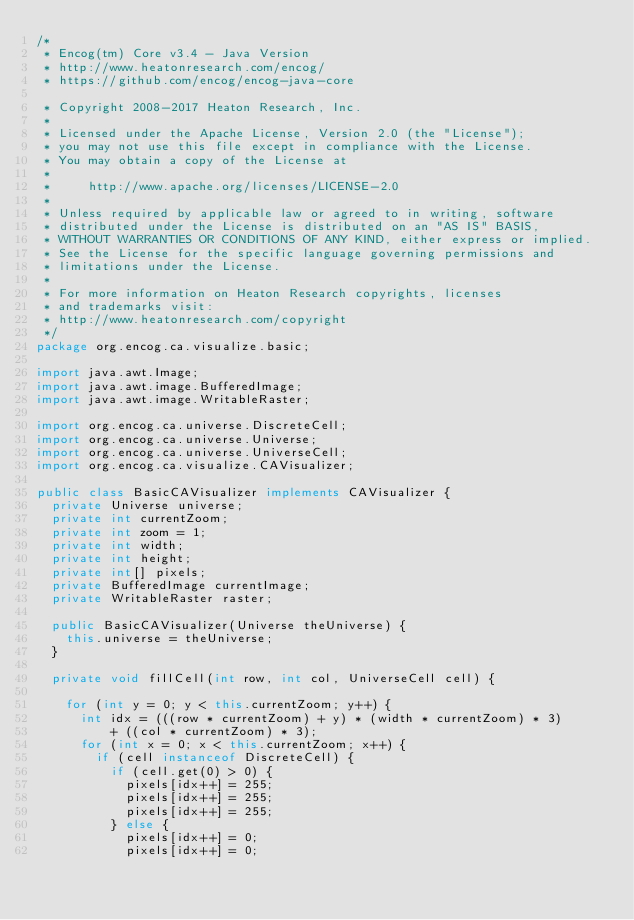<code> <loc_0><loc_0><loc_500><loc_500><_Java_>/*
 * Encog(tm) Core v3.4 - Java Version
 * http://www.heatonresearch.com/encog/
 * https://github.com/encog/encog-java-core
 
 * Copyright 2008-2017 Heaton Research, Inc.
 *
 * Licensed under the Apache License, Version 2.0 (the "License");
 * you may not use this file except in compliance with the License.
 * You may obtain a copy of the License at
 *
 *     http://www.apache.org/licenses/LICENSE-2.0
 *
 * Unless required by applicable law or agreed to in writing, software
 * distributed under the License is distributed on an "AS IS" BASIS,
 * WITHOUT WARRANTIES OR CONDITIONS OF ANY KIND, either express or implied.
 * See the License for the specific language governing permissions and
 * limitations under the License.
 *   
 * For more information on Heaton Research copyrights, licenses 
 * and trademarks visit:
 * http://www.heatonresearch.com/copyright
 */
package org.encog.ca.visualize.basic;

import java.awt.Image;
import java.awt.image.BufferedImage;
import java.awt.image.WritableRaster;

import org.encog.ca.universe.DiscreteCell;
import org.encog.ca.universe.Universe;
import org.encog.ca.universe.UniverseCell;
import org.encog.ca.visualize.CAVisualizer;

public class BasicCAVisualizer implements CAVisualizer {
	private Universe universe;
	private int currentZoom;
	private int zoom = 1;
	private int width;
	private int height;
	private int[] pixels;
	private BufferedImage currentImage;
	private WritableRaster raster;

	public BasicCAVisualizer(Universe theUniverse) {
		this.universe = theUniverse;
	}

	private void fillCell(int row, int col, UniverseCell cell) {

		for (int y = 0; y < this.currentZoom; y++) {
			int idx = (((row * currentZoom) + y) * (width * currentZoom) * 3)
					+ ((col * currentZoom) * 3);
			for (int x = 0; x < this.currentZoom; x++) {
				if (cell instanceof DiscreteCell) {
					if (cell.get(0) > 0) {
						pixels[idx++] = 255;
						pixels[idx++] = 255;
						pixels[idx++] = 255;
					} else {
						pixels[idx++] = 0;
						pixels[idx++] = 0;</code> 